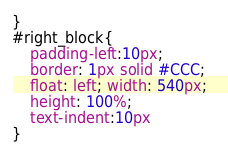Convert code to text. <code><loc_0><loc_0><loc_500><loc_500><_CSS_>}
#right_block{
	padding-left:10px; 
	border: 1px solid #CCC; 
	float: left; width: 540px;  
	height: 100%; 
	text-indent:10px
}
</code> 